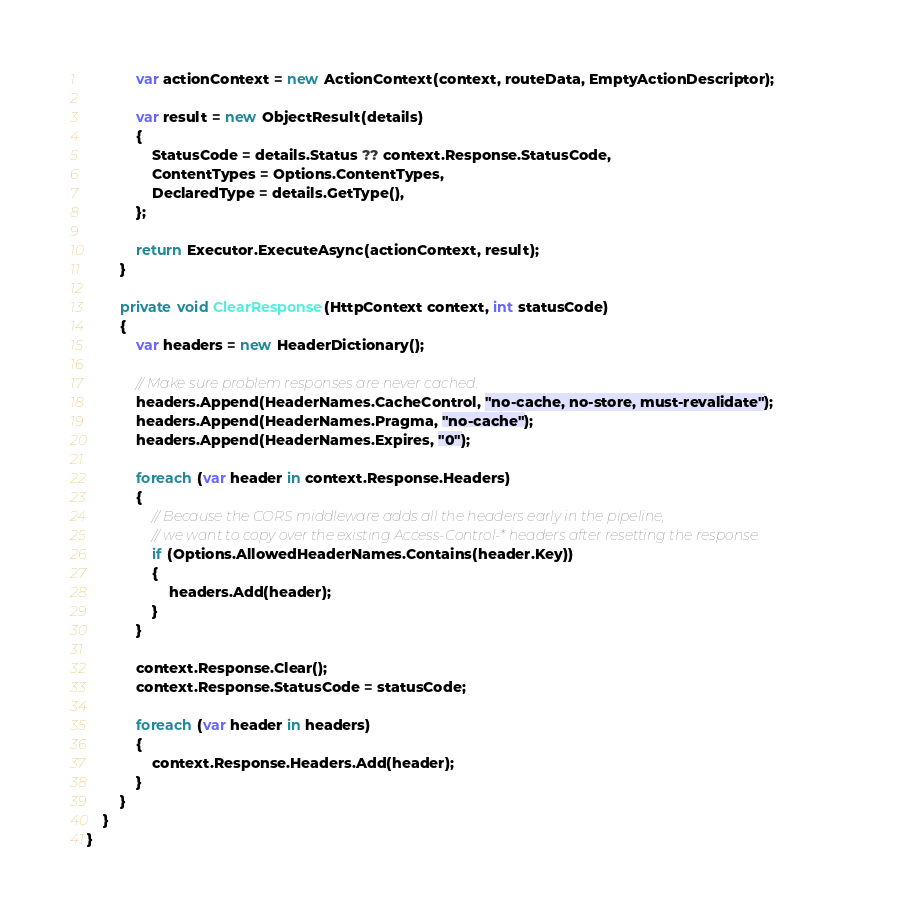<code> <loc_0><loc_0><loc_500><loc_500><_C#_>            var actionContext = new ActionContext(context, routeData, EmptyActionDescriptor);

            var result = new ObjectResult(details)
            {
                StatusCode = details.Status ?? context.Response.StatusCode,
                ContentTypes = Options.ContentTypes,
                DeclaredType = details.GetType(),
            };

            return Executor.ExecuteAsync(actionContext, result);
        }

        private void ClearResponse(HttpContext context, int statusCode)
        {
            var headers = new HeaderDictionary();

            // Make sure problem responses are never cached.
            headers.Append(HeaderNames.CacheControl, "no-cache, no-store, must-revalidate");
            headers.Append(HeaderNames.Pragma, "no-cache");
            headers.Append(HeaderNames.Expires, "0");

            foreach (var header in context.Response.Headers)
            {
                // Because the CORS middleware adds all the headers early in the pipeline,
                // we want to copy over the existing Access-Control-* headers after resetting the response.
                if (Options.AllowedHeaderNames.Contains(header.Key))
                {
                    headers.Add(header);
                }
            }

            context.Response.Clear();
            context.Response.StatusCode = statusCode;

            foreach (var header in headers)
            {
                context.Response.Headers.Add(header);
            }
        }
    }
}
</code> 